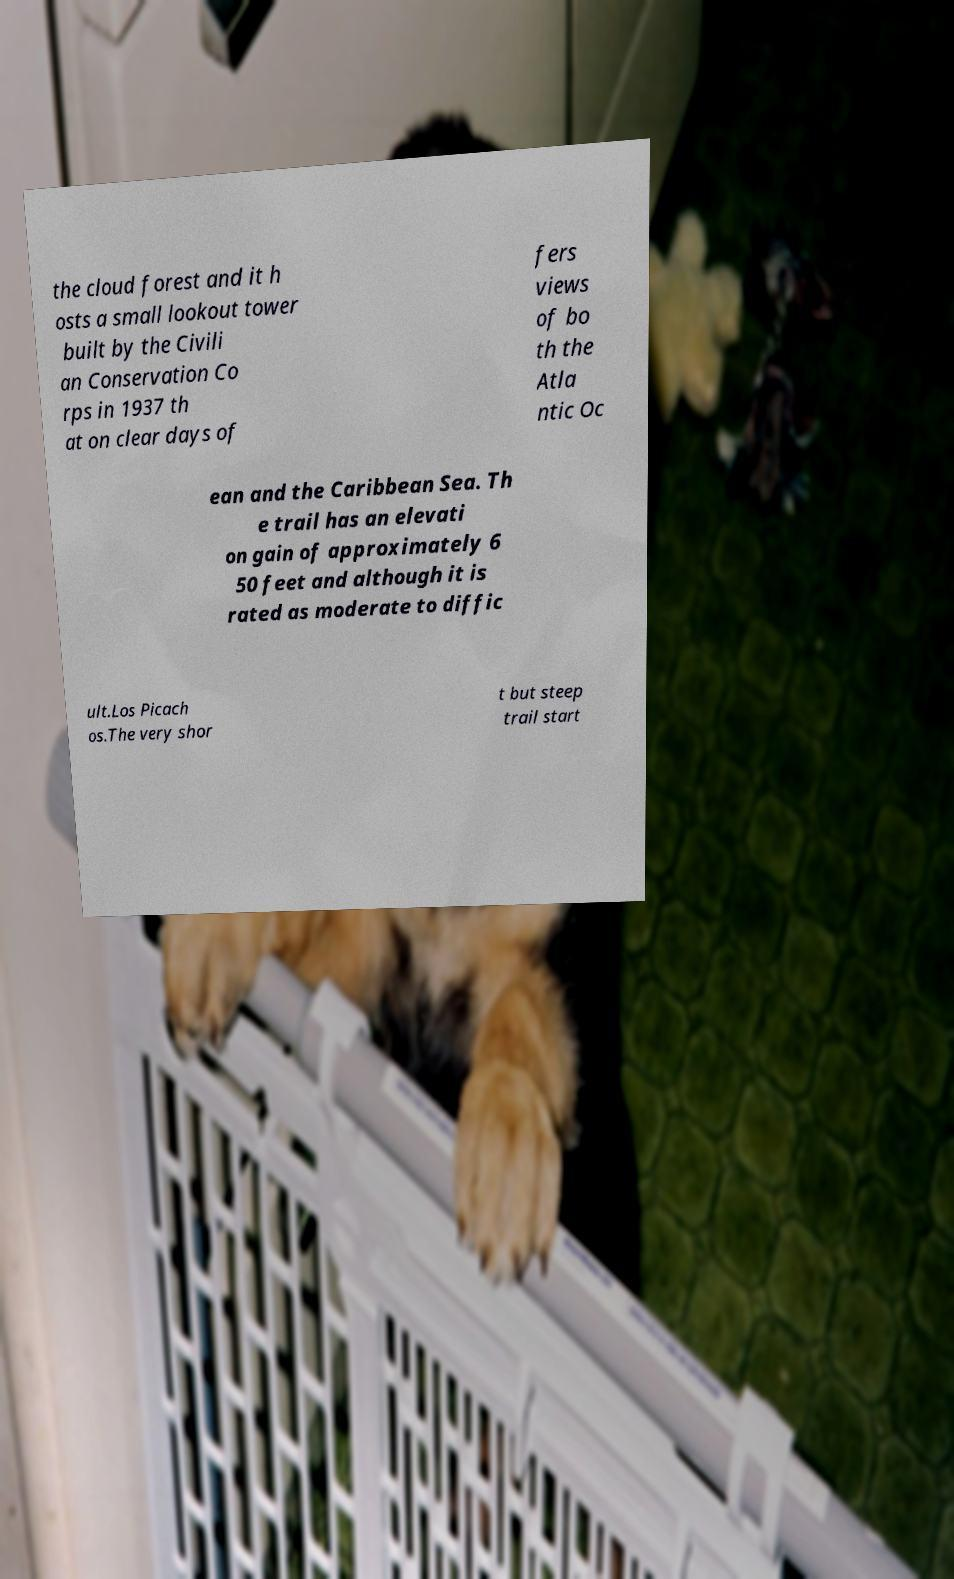Please identify and transcribe the text found in this image. the cloud forest and it h osts a small lookout tower built by the Civili an Conservation Co rps in 1937 th at on clear days of fers views of bo th the Atla ntic Oc ean and the Caribbean Sea. Th e trail has an elevati on gain of approximately 6 50 feet and although it is rated as moderate to diffic ult.Los Picach os.The very shor t but steep trail start 